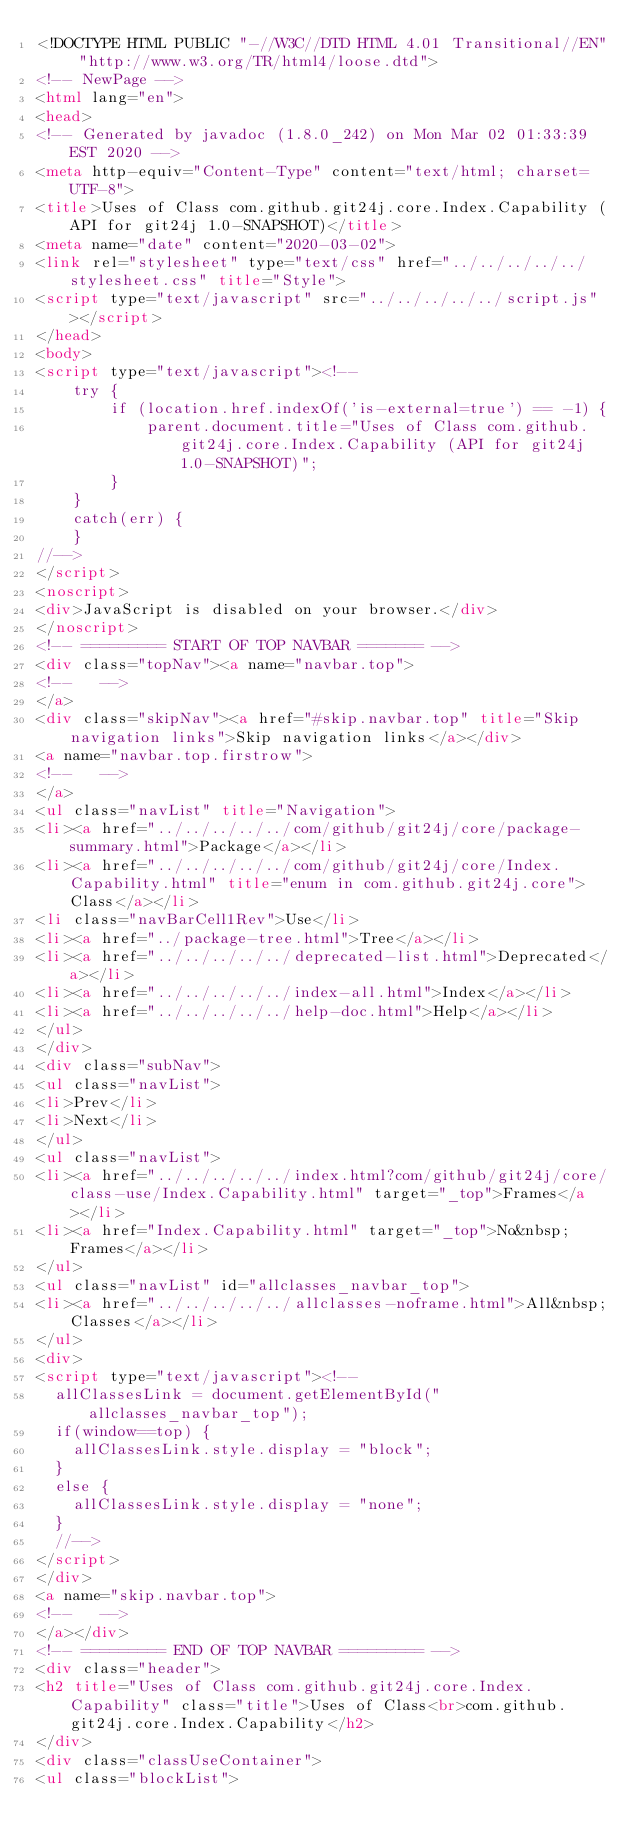<code> <loc_0><loc_0><loc_500><loc_500><_HTML_><!DOCTYPE HTML PUBLIC "-//W3C//DTD HTML 4.01 Transitional//EN" "http://www.w3.org/TR/html4/loose.dtd">
<!-- NewPage -->
<html lang="en">
<head>
<!-- Generated by javadoc (1.8.0_242) on Mon Mar 02 01:33:39 EST 2020 -->
<meta http-equiv="Content-Type" content="text/html; charset=UTF-8">
<title>Uses of Class com.github.git24j.core.Index.Capability (API for git24j 1.0-SNAPSHOT)</title>
<meta name="date" content="2020-03-02">
<link rel="stylesheet" type="text/css" href="../../../../../stylesheet.css" title="Style">
<script type="text/javascript" src="../../../../../script.js"></script>
</head>
<body>
<script type="text/javascript"><!--
    try {
        if (location.href.indexOf('is-external=true') == -1) {
            parent.document.title="Uses of Class com.github.git24j.core.Index.Capability (API for git24j 1.0-SNAPSHOT)";
        }
    }
    catch(err) {
    }
//-->
</script>
<noscript>
<div>JavaScript is disabled on your browser.</div>
</noscript>
<!-- ========= START OF TOP NAVBAR ======= -->
<div class="topNav"><a name="navbar.top">
<!--   -->
</a>
<div class="skipNav"><a href="#skip.navbar.top" title="Skip navigation links">Skip navigation links</a></div>
<a name="navbar.top.firstrow">
<!--   -->
</a>
<ul class="navList" title="Navigation">
<li><a href="../../../../../com/github/git24j/core/package-summary.html">Package</a></li>
<li><a href="../../../../../com/github/git24j/core/Index.Capability.html" title="enum in com.github.git24j.core">Class</a></li>
<li class="navBarCell1Rev">Use</li>
<li><a href="../package-tree.html">Tree</a></li>
<li><a href="../../../../../deprecated-list.html">Deprecated</a></li>
<li><a href="../../../../../index-all.html">Index</a></li>
<li><a href="../../../../../help-doc.html">Help</a></li>
</ul>
</div>
<div class="subNav">
<ul class="navList">
<li>Prev</li>
<li>Next</li>
</ul>
<ul class="navList">
<li><a href="../../../../../index.html?com/github/git24j/core/class-use/Index.Capability.html" target="_top">Frames</a></li>
<li><a href="Index.Capability.html" target="_top">No&nbsp;Frames</a></li>
</ul>
<ul class="navList" id="allclasses_navbar_top">
<li><a href="../../../../../allclasses-noframe.html">All&nbsp;Classes</a></li>
</ul>
<div>
<script type="text/javascript"><!--
  allClassesLink = document.getElementById("allclasses_navbar_top");
  if(window==top) {
    allClassesLink.style.display = "block";
  }
  else {
    allClassesLink.style.display = "none";
  }
  //-->
</script>
</div>
<a name="skip.navbar.top">
<!--   -->
</a></div>
<!-- ========= END OF TOP NAVBAR ========= -->
<div class="header">
<h2 title="Uses of Class com.github.git24j.core.Index.Capability" class="title">Uses of Class<br>com.github.git24j.core.Index.Capability</h2>
</div>
<div class="classUseContainer">
<ul class="blockList"></code> 